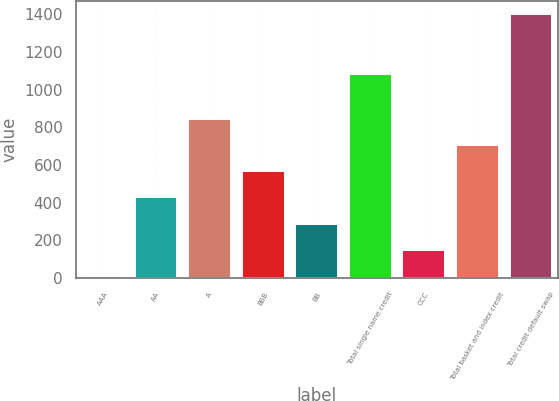<chart> <loc_0><loc_0><loc_500><loc_500><bar_chart><fcel>AAA<fcel>AA<fcel>A<fcel>BBB<fcel>BB<fcel>Total single name credit<fcel>CCC<fcel>Total basket and index credit<fcel>Total credit default swap<nl><fcel>10<fcel>426.97<fcel>843.94<fcel>565.96<fcel>287.98<fcel>1084.9<fcel>148.99<fcel>704.95<fcel>1399.9<nl></chart> 